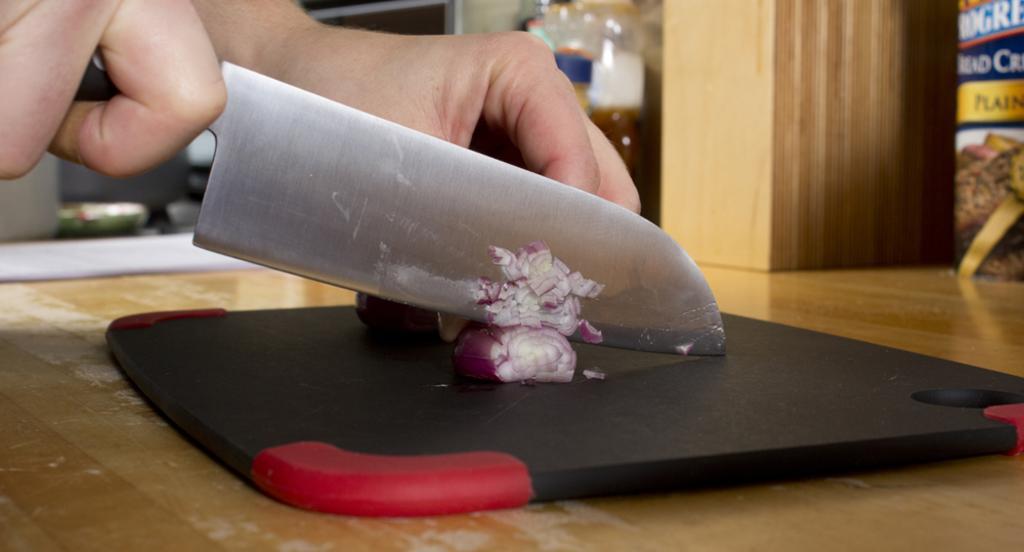In one or two sentences, can you explain what this image depicts? In this image, I see a person's hand and the person is chopping an onion with the help of a knife on a chopping board. 